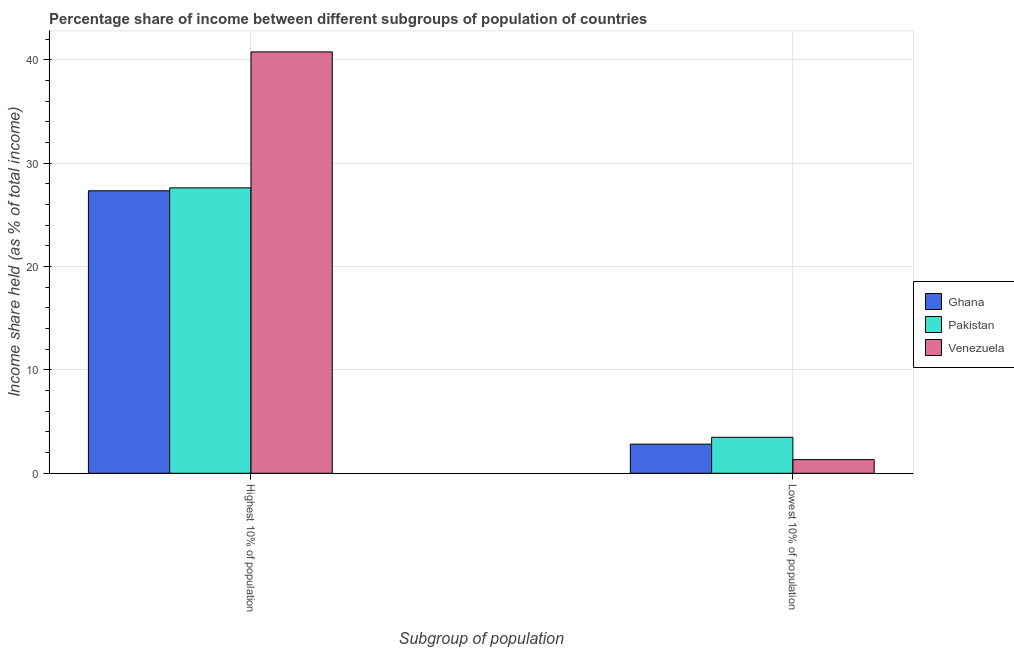How many different coloured bars are there?
Offer a terse response. 3. Are the number of bars per tick equal to the number of legend labels?
Make the answer very short. Yes. Are the number of bars on each tick of the X-axis equal?
Provide a succinct answer. Yes. What is the label of the 1st group of bars from the left?
Your answer should be very brief. Highest 10% of population. What is the income share held by lowest 10% of the population in Ghana?
Your answer should be compact. 2.82. Across all countries, what is the maximum income share held by highest 10% of the population?
Offer a terse response. 40.78. Across all countries, what is the minimum income share held by highest 10% of the population?
Provide a succinct answer. 27.34. In which country was the income share held by lowest 10% of the population minimum?
Provide a succinct answer. Venezuela. What is the total income share held by highest 10% of the population in the graph?
Your response must be concise. 95.74. What is the difference between the income share held by highest 10% of the population in Pakistan and that in Venezuela?
Your answer should be compact. -13.16. What is the difference between the income share held by lowest 10% of the population in Pakistan and the income share held by highest 10% of the population in Venezuela?
Give a very brief answer. -37.3. What is the average income share held by lowest 10% of the population per country?
Provide a succinct answer. 2.54. What is the difference between the income share held by lowest 10% of the population and income share held by highest 10% of the population in Pakistan?
Ensure brevity in your answer.  -24.14. In how many countries, is the income share held by lowest 10% of the population greater than 10 %?
Keep it short and to the point. 0. What is the ratio of the income share held by highest 10% of the population in Ghana to that in Pakistan?
Ensure brevity in your answer.  0.99. In how many countries, is the income share held by highest 10% of the population greater than the average income share held by highest 10% of the population taken over all countries?
Give a very brief answer. 1. What does the 3rd bar from the left in Lowest 10% of population represents?
Your answer should be very brief. Venezuela. What does the 1st bar from the right in Lowest 10% of population represents?
Give a very brief answer. Venezuela. How many bars are there?
Provide a short and direct response. 6. Are all the bars in the graph horizontal?
Give a very brief answer. No. How many countries are there in the graph?
Your answer should be very brief. 3. What is the difference between two consecutive major ticks on the Y-axis?
Your answer should be compact. 10. How are the legend labels stacked?
Your response must be concise. Vertical. What is the title of the graph?
Your answer should be very brief. Percentage share of income between different subgroups of population of countries. Does "Bahrain" appear as one of the legend labels in the graph?
Keep it short and to the point. No. What is the label or title of the X-axis?
Ensure brevity in your answer.  Subgroup of population. What is the label or title of the Y-axis?
Your answer should be very brief. Income share held (as % of total income). What is the Income share held (as % of total income) of Ghana in Highest 10% of population?
Your answer should be very brief. 27.34. What is the Income share held (as % of total income) of Pakistan in Highest 10% of population?
Offer a terse response. 27.62. What is the Income share held (as % of total income) of Venezuela in Highest 10% of population?
Provide a succinct answer. 40.78. What is the Income share held (as % of total income) in Ghana in Lowest 10% of population?
Keep it short and to the point. 2.82. What is the Income share held (as % of total income) of Pakistan in Lowest 10% of population?
Keep it short and to the point. 3.48. What is the Income share held (as % of total income) in Venezuela in Lowest 10% of population?
Provide a succinct answer. 1.32. Across all Subgroup of population, what is the maximum Income share held (as % of total income) of Ghana?
Your answer should be very brief. 27.34. Across all Subgroup of population, what is the maximum Income share held (as % of total income) in Pakistan?
Your answer should be very brief. 27.62. Across all Subgroup of population, what is the maximum Income share held (as % of total income) in Venezuela?
Your response must be concise. 40.78. Across all Subgroup of population, what is the minimum Income share held (as % of total income) in Ghana?
Your answer should be compact. 2.82. Across all Subgroup of population, what is the minimum Income share held (as % of total income) of Pakistan?
Make the answer very short. 3.48. Across all Subgroup of population, what is the minimum Income share held (as % of total income) of Venezuela?
Offer a terse response. 1.32. What is the total Income share held (as % of total income) of Ghana in the graph?
Offer a very short reply. 30.16. What is the total Income share held (as % of total income) in Pakistan in the graph?
Your answer should be very brief. 31.1. What is the total Income share held (as % of total income) in Venezuela in the graph?
Make the answer very short. 42.1. What is the difference between the Income share held (as % of total income) in Ghana in Highest 10% of population and that in Lowest 10% of population?
Provide a short and direct response. 24.52. What is the difference between the Income share held (as % of total income) of Pakistan in Highest 10% of population and that in Lowest 10% of population?
Make the answer very short. 24.14. What is the difference between the Income share held (as % of total income) of Venezuela in Highest 10% of population and that in Lowest 10% of population?
Ensure brevity in your answer.  39.46. What is the difference between the Income share held (as % of total income) in Ghana in Highest 10% of population and the Income share held (as % of total income) in Pakistan in Lowest 10% of population?
Keep it short and to the point. 23.86. What is the difference between the Income share held (as % of total income) of Ghana in Highest 10% of population and the Income share held (as % of total income) of Venezuela in Lowest 10% of population?
Keep it short and to the point. 26.02. What is the difference between the Income share held (as % of total income) of Pakistan in Highest 10% of population and the Income share held (as % of total income) of Venezuela in Lowest 10% of population?
Offer a very short reply. 26.3. What is the average Income share held (as % of total income) of Ghana per Subgroup of population?
Ensure brevity in your answer.  15.08. What is the average Income share held (as % of total income) in Pakistan per Subgroup of population?
Your answer should be compact. 15.55. What is the average Income share held (as % of total income) in Venezuela per Subgroup of population?
Offer a terse response. 21.05. What is the difference between the Income share held (as % of total income) in Ghana and Income share held (as % of total income) in Pakistan in Highest 10% of population?
Offer a very short reply. -0.28. What is the difference between the Income share held (as % of total income) in Ghana and Income share held (as % of total income) in Venezuela in Highest 10% of population?
Your answer should be very brief. -13.44. What is the difference between the Income share held (as % of total income) in Pakistan and Income share held (as % of total income) in Venezuela in Highest 10% of population?
Your response must be concise. -13.16. What is the difference between the Income share held (as % of total income) of Ghana and Income share held (as % of total income) of Pakistan in Lowest 10% of population?
Offer a very short reply. -0.66. What is the difference between the Income share held (as % of total income) of Ghana and Income share held (as % of total income) of Venezuela in Lowest 10% of population?
Offer a terse response. 1.5. What is the difference between the Income share held (as % of total income) in Pakistan and Income share held (as % of total income) in Venezuela in Lowest 10% of population?
Your answer should be compact. 2.16. What is the ratio of the Income share held (as % of total income) in Ghana in Highest 10% of population to that in Lowest 10% of population?
Offer a terse response. 9.7. What is the ratio of the Income share held (as % of total income) of Pakistan in Highest 10% of population to that in Lowest 10% of population?
Provide a short and direct response. 7.94. What is the ratio of the Income share held (as % of total income) in Venezuela in Highest 10% of population to that in Lowest 10% of population?
Give a very brief answer. 30.89. What is the difference between the highest and the second highest Income share held (as % of total income) of Ghana?
Offer a very short reply. 24.52. What is the difference between the highest and the second highest Income share held (as % of total income) in Pakistan?
Make the answer very short. 24.14. What is the difference between the highest and the second highest Income share held (as % of total income) in Venezuela?
Your answer should be very brief. 39.46. What is the difference between the highest and the lowest Income share held (as % of total income) in Ghana?
Ensure brevity in your answer.  24.52. What is the difference between the highest and the lowest Income share held (as % of total income) of Pakistan?
Your response must be concise. 24.14. What is the difference between the highest and the lowest Income share held (as % of total income) in Venezuela?
Keep it short and to the point. 39.46. 